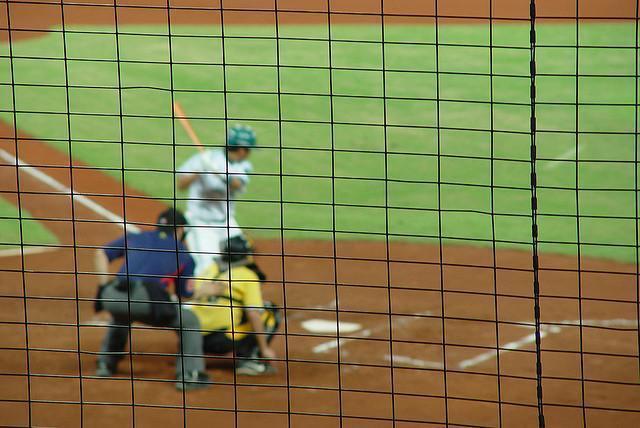How many people are in the photo?
Give a very brief answer. 3. 